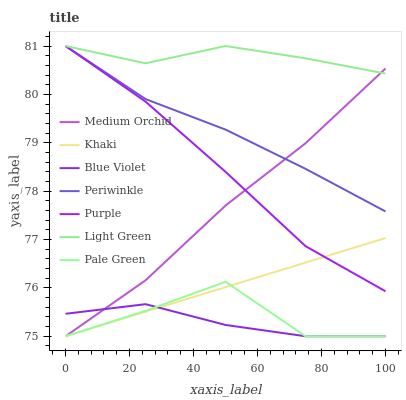Does Purple have the minimum area under the curve?
Answer yes or no. No. Does Purple have the maximum area under the curve?
Answer yes or no. No. Is Purple the smoothest?
Answer yes or no. No. Is Purple the roughest?
Answer yes or no. No. Does Purple have the lowest value?
Answer yes or no. No. Does Medium Orchid have the highest value?
Answer yes or no. No. Is Khaki less than Periwinkle?
Answer yes or no. Yes. Is Light Green greater than Pale Green?
Answer yes or no. Yes. Does Khaki intersect Periwinkle?
Answer yes or no. No. 